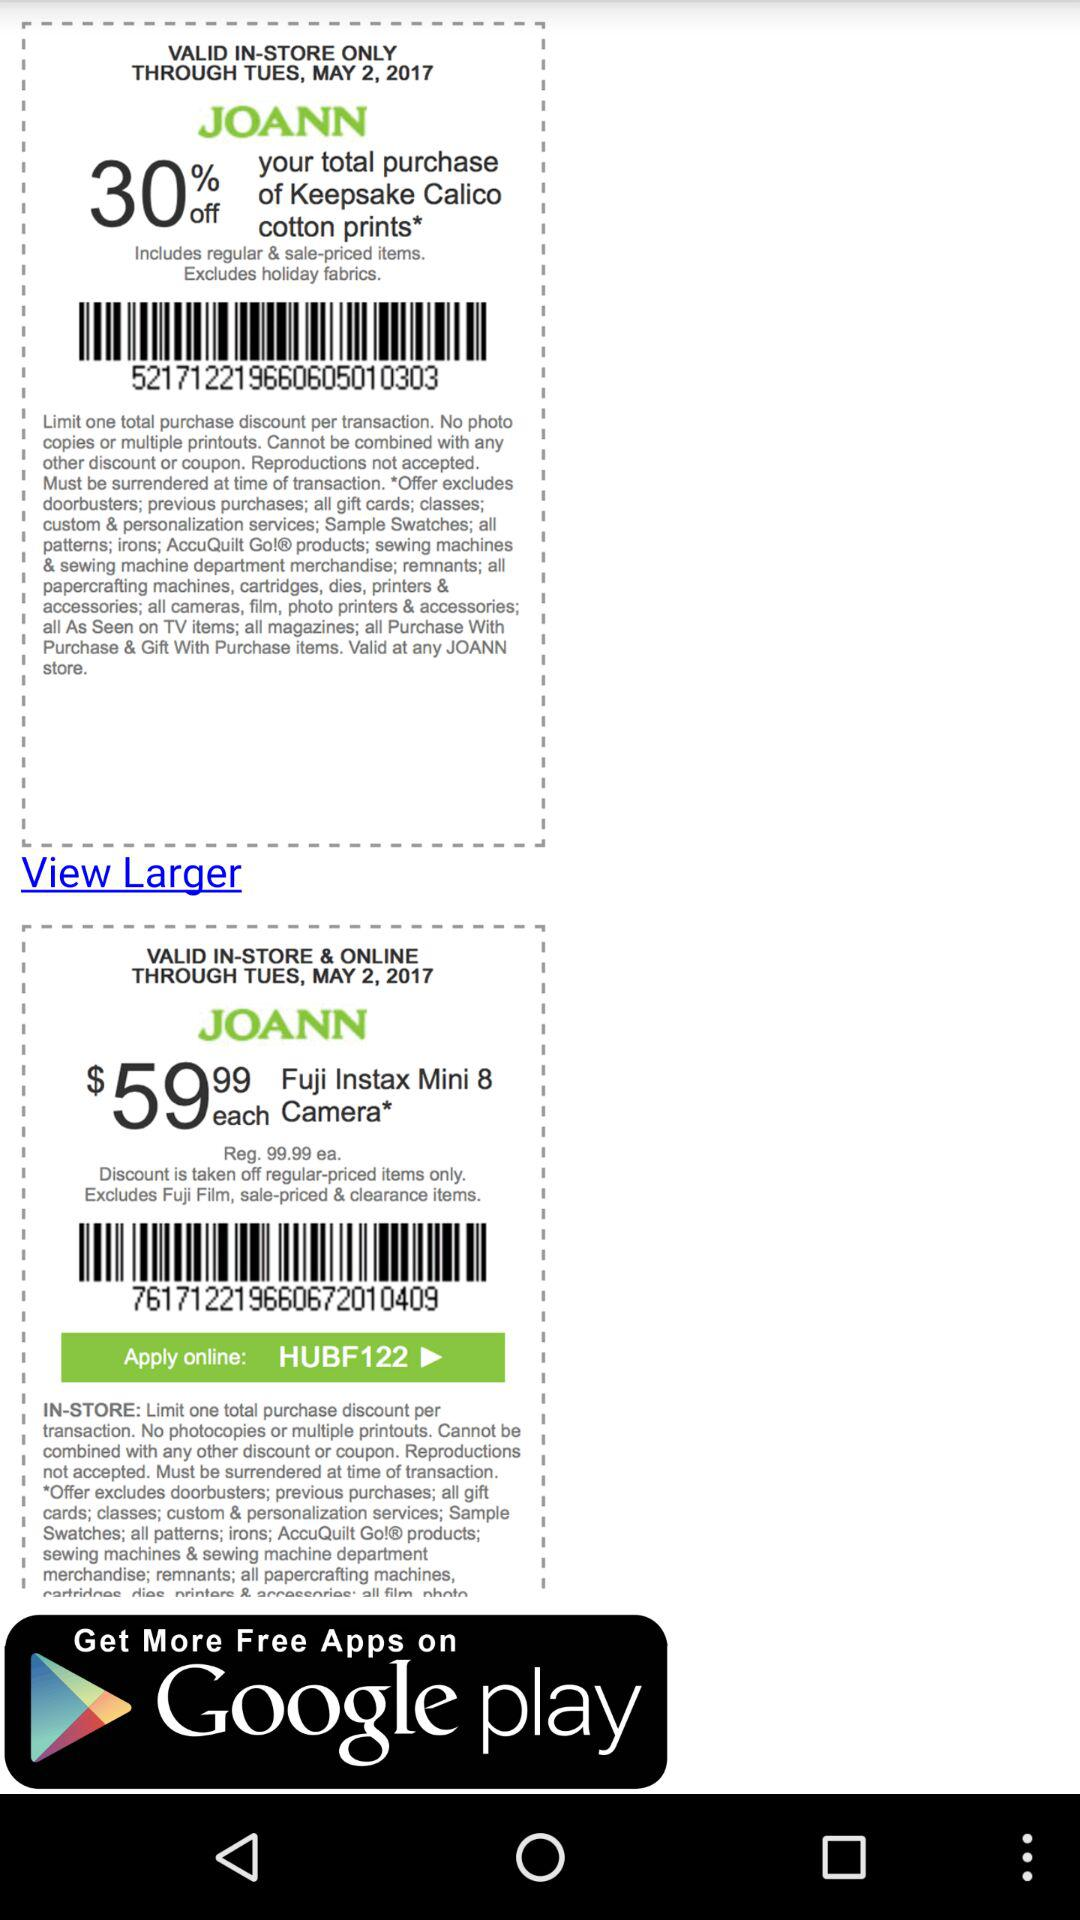How many coupons are there on this screen?
Answer the question using a single word or phrase. 2 